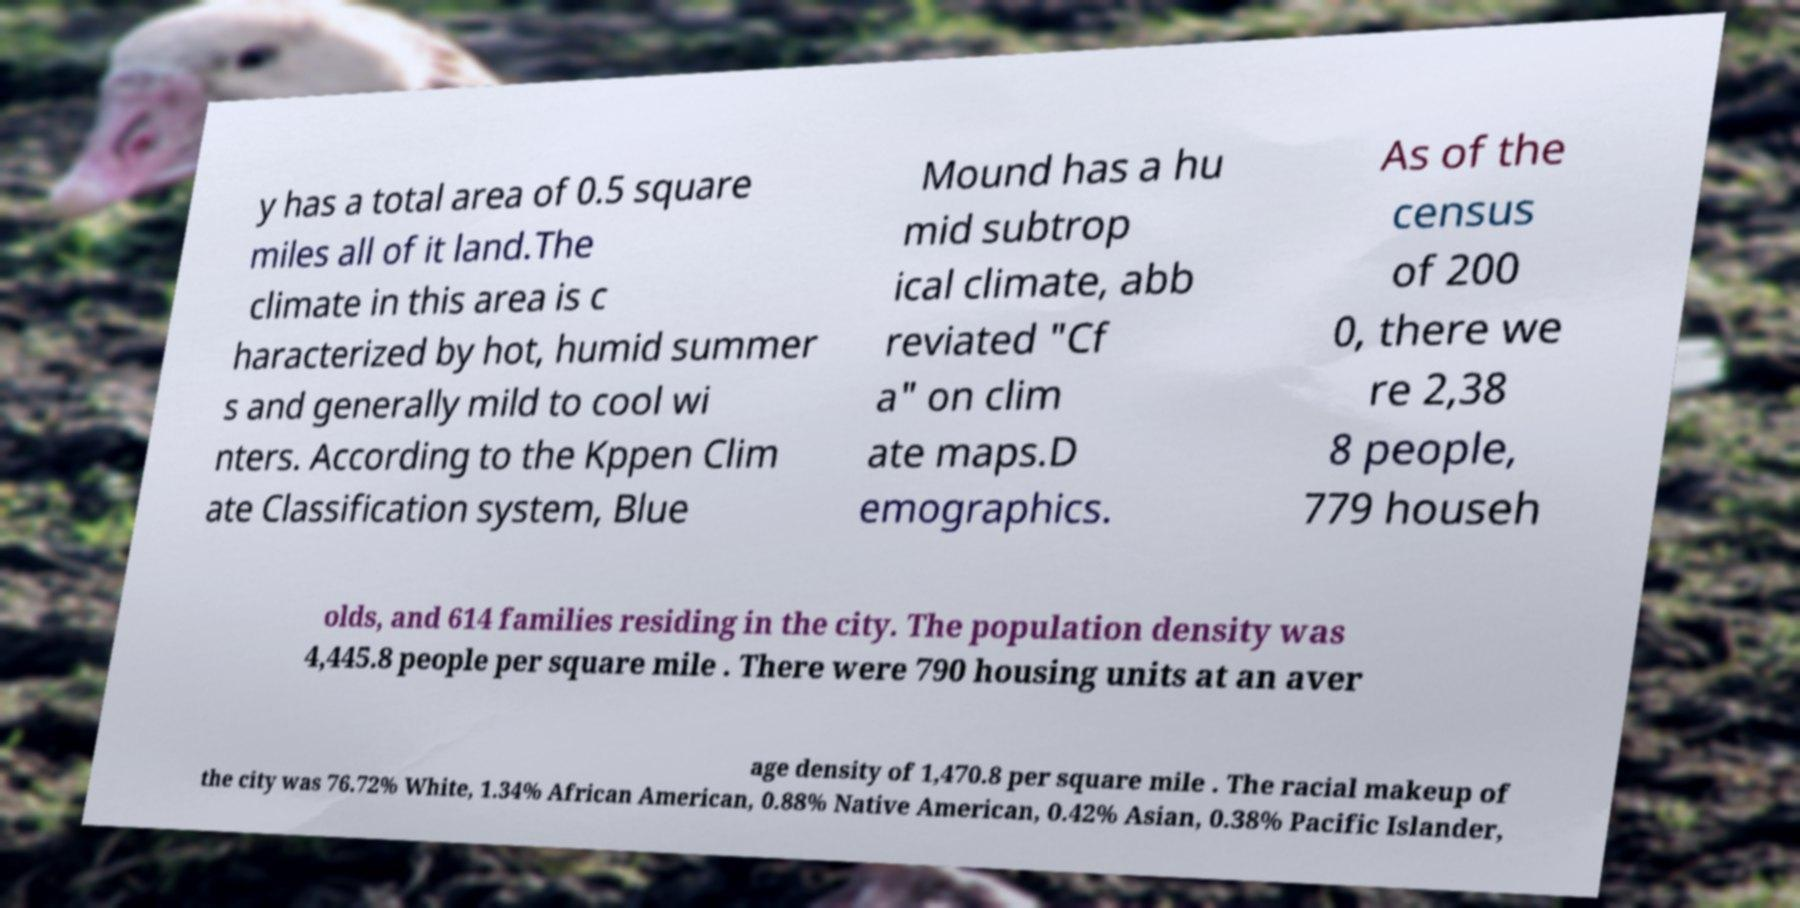Could you assist in decoding the text presented in this image and type it out clearly? y has a total area of 0.5 square miles all of it land.The climate in this area is c haracterized by hot, humid summer s and generally mild to cool wi nters. According to the Kppen Clim ate Classification system, Blue Mound has a hu mid subtrop ical climate, abb reviated "Cf a" on clim ate maps.D emographics. As of the census of 200 0, there we re 2,38 8 people, 779 househ olds, and 614 families residing in the city. The population density was 4,445.8 people per square mile . There were 790 housing units at an aver age density of 1,470.8 per square mile . The racial makeup of the city was 76.72% White, 1.34% African American, 0.88% Native American, 0.42% Asian, 0.38% Pacific Islander, 